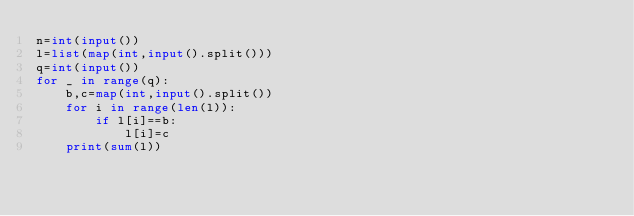Convert code to text. <code><loc_0><loc_0><loc_500><loc_500><_Python_>n=int(input())
l=list(map(int,input().split()))
q=int(input())
for _ in range(q):
    b,c=map(int,input().split())
    for i in range(len(l)):
        if l[i]==b:
            l[i]=c
    print(sum(l))</code> 